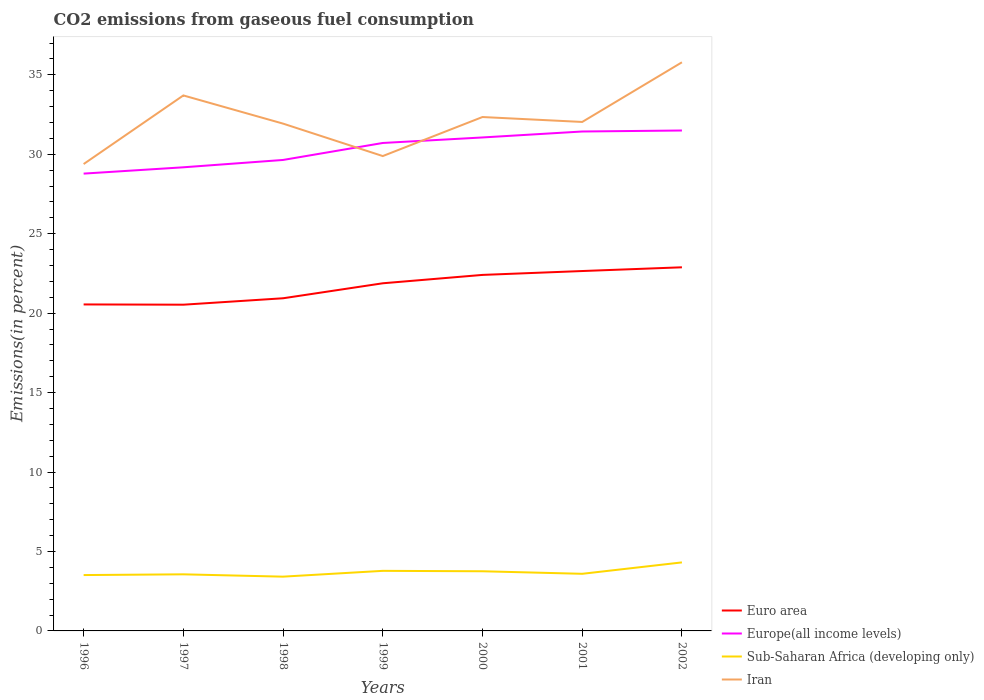Is the number of lines equal to the number of legend labels?
Offer a very short reply. Yes. Across all years, what is the maximum total CO2 emitted in Europe(all income levels)?
Make the answer very short. 28.78. In which year was the total CO2 emitted in Euro area maximum?
Ensure brevity in your answer.  1997. What is the total total CO2 emitted in Sub-Saharan Africa (developing only) in the graph?
Ensure brevity in your answer.  -0.34. What is the difference between the highest and the second highest total CO2 emitted in Iran?
Offer a terse response. 6.4. What is the difference between the highest and the lowest total CO2 emitted in Iran?
Give a very brief answer. 3. How many lines are there?
Offer a terse response. 4. How many years are there in the graph?
Your answer should be very brief. 7. What is the difference between two consecutive major ticks on the Y-axis?
Provide a succinct answer. 5. Does the graph contain grids?
Your answer should be very brief. No. How many legend labels are there?
Offer a very short reply. 4. How are the legend labels stacked?
Provide a succinct answer. Vertical. What is the title of the graph?
Your answer should be very brief. CO2 emissions from gaseous fuel consumption. What is the label or title of the Y-axis?
Your answer should be very brief. Emissions(in percent). What is the Emissions(in percent) of Euro area in 1996?
Make the answer very short. 20.55. What is the Emissions(in percent) of Europe(all income levels) in 1996?
Provide a succinct answer. 28.78. What is the Emissions(in percent) in Sub-Saharan Africa (developing only) in 1996?
Make the answer very short. 3.52. What is the Emissions(in percent) in Iran in 1996?
Ensure brevity in your answer.  29.38. What is the Emissions(in percent) of Euro area in 1997?
Make the answer very short. 20.53. What is the Emissions(in percent) in Europe(all income levels) in 1997?
Make the answer very short. 29.18. What is the Emissions(in percent) in Sub-Saharan Africa (developing only) in 1997?
Give a very brief answer. 3.56. What is the Emissions(in percent) of Iran in 1997?
Your response must be concise. 33.7. What is the Emissions(in percent) in Euro area in 1998?
Provide a succinct answer. 20.94. What is the Emissions(in percent) in Europe(all income levels) in 1998?
Keep it short and to the point. 29.64. What is the Emissions(in percent) of Sub-Saharan Africa (developing only) in 1998?
Your answer should be compact. 3.42. What is the Emissions(in percent) of Iran in 1998?
Ensure brevity in your answer.  31.93. What is the Emissions(in percent) of Euro area in 1999?
Keep it short and to the point. 21.88. What is the Emissions(in percent) in Europe(all income levels) in 1999?
Make the answer very short. 30.71. What is the Emissions(in percent) of Sub-Saharan Africa (developing only) in 1999?
Offer a very short reply. 3.78. What is the Emissions(in percent) of Iran in 1999?
Give a very brief answer. 29.89. What is the Emissions(in percent) in Euro area in 2000?
Your answer should be compact. 22.41. What is the Emissions(in percent) of Europe(all income levels) in 2000?
Make the answer very short. 31.06. What is the Emissions(in percent) of Sub-Saharan Africa (developing only) in 2000?
Your answer should be very brief. 3.75. What is the Emissions(in percent) in Iran in 2000?
Make the answer very short. 32.34. What is the Emissions(in percent) of Euro area in 2001?
Your answer should be very brief. 22.65. What is the Emissions(in percent) in Europe(all income levels) in 2001?
Keep it short and to the point. 31.43. What is the Emissions(in percent) in Sub-Saharan Africa (developing only) in 2001?
Give a very brief answer. 3.59. What is the Emissions(in percent) of Iran in 2001?
Your answer should be compact. 32.03. What is the Emissions(in percent) of Euro area in 2002?
Provide a succinct answer. 22.89. What is the Emissions(in percent) of Europe(all income levels) in 2002?
Ensure brevity in your answer.  31.5. What is the Emissions(in percent) of Sub-Saharan Africa (developing only) in 2002?
Your answer should be compact. 4.31. What is the Emissions(in percent) in Iran in 2002?
Give a very brief answer. 35.79. Across all years, what is the maximum Emissions(in percent) of Euro area?
Ensure brevity in your answer.  22.89. Across all years, what is the maximum Emissions(in percent) in Europe(all income levels)?
Keep it short and to the point. 31.5. Across all years, what is the maximum Emissions(in percent) of Sub-Saharan Africa (developing only)?
Provide a succinct answer. 4.31. Across all years, what is the maximum Emissions(in percent) in Iran?
Offer a terse response. 35.79. Across all years, what is the minimum Emissions(in percent) in Euro area?
Keep it short and to the point. 20.53. Across all years, what is the minimum Emissions(in percent) of Europe(all income levels)?
Offer a very short reply. 28.78. Across all years, what is the minimum Emissions(in percent) in Sub-Saharan Africa (developing only)?
Offer a very short reply. 3.42. Across all years, what is the minimum Emissions(in percent) of Iran?
Make the answer very short. 29.38. What is the total Emissions(in percent) in Euro area in the graph?
Your response must be concise. 151.84. What is the total Emissions(in percent) in Europe(all income levels) in the graph?
Your answer should be very brief. 212.3. What is the total Emissions(in percent) in Sub-Saharan Africa (developing only) in the graph?
Your answer should be very brief. 25.94. What is the total Emissions(in percent) of Iran in the graph?
Your answer should be compact. 225.07. What is the difference between the Emissions(in percent) of Euro area in 1996 and that in 1997?
Provide a short and direct response. 0.02. What is the difference between the Emissions(in percent) of Europe(all income levels) in 1996 and that in 1997?
Give a very brief answer. -0.4. What is the difference between the Emissions(in percent) in Sub-Saharan Africa (developing only) in 1996 and that in 1997?
Provide a short and direct response. -0.05. What is the difference between the Emissions(in percent) in Iran in 1996 and that in 1997?
Give a very brief answer. -4.32. What is the difference between the Emissions(in percent) in Euro area in 1996 and that in 1998?
Provide a short and direct response. -0.39. What is the difference between the Emissions(in percent) in Europe(all income levels) in 1996 and that in 1998?
Your answer should be compact. -0.86. What is the difference between the Emissions(in percent) in Sub-Saharan Africa (developing only) in 1996 and that in 1998?
Offer a terse response. 0.1. What is the difference between the Emissions(in percent) in Iran in 1996 and that in 1998?
Provide a short and direct response. -2.55. What is the difference between the Emissions(in percent) of Euro area in 1996 and that in 1999?
Your response must be concise. -1.33. What is the difference between the Emissions(in percent) of Europe(all income levels) in 1996 and that in 1999?
Your answer should be compact. -1.93. What is the difference between the Emissions(in percent) in Sub-Saharan Africa (developing only) in 1996 and that in 1999?
Provide a succinct answer. -0.27. What is the difference between the Emissions(in percent) in Iran in 1996 and that in 1999?
Your answer should be compact. -0.5. What is the difference between the Emissions(in percent) in Euro area in 1996 and that in 2000?
Provide a succinct answer. -1.86. What is the difference between the Emissions(in percent) in Europe(all income levels) in 1996 and that in 2000?
Offer a very short reply. -2.28. What is the difference between the Emissions(in percent) in Sub-Saharan Africa (developing only) in 1996 and that in 2000?
Provide a succinct answer. -0.24. What is the difference between the Emissions(in percent) of Iran in 1996 and that in 2000?
Provide a short and direct response. -2.96. What is the difference between the Emissions(in percent) in Euro area in 1996 and that in 2001?
Your response must be concise. -2.1. What is the difference between the Emissions(in percent) in Europe(all income levels) in 1996 and that in 2001?
Provide a short and direct response. -2.65. What is the difference between the Emissions(in percent) of Sub-Saharan Africa (developing only) in 1996 and that in 2001?
Make the answer very short. -0.08. What is the difference between the Emissions(in percent) of Iran in 1996 and that in 2001?
Keep it short and to the point. -2.65. What is the difference between the Emissions(in percent) of Euro area in 1996 and that in 2002?
Provide a succinct answer. -2.34. What is the difference between the Emissions(in percent) in Europe(all income levels) in 1996 and that in 2002?
Your answer should be very brief. -2.71. What is the difference between the Emissions(in percent) of Sub-Saharan Africa (developing only) in 1996 and that in 2002?
Offer a terse response. -0.8. What is the difference between the Emissions(in percent) in Iran in 1996 and that in 2002?
Make the answer very short. -6.4. What is the difference between the Emissions(in percent) in Euro area in 1997 and that in 1998?
Offer a very short reply. -0.4. What is the difference between the Emissions(in percent) of Europe(all income levels) in 1997 and that in 1998?
Offer a terse response. -0.46. What is the difference between the Emissions(in percent) of Sub-Saharan Africa (developing only) in 1997 and that in 1998?
Provide a short and direct response. 0.15. What is the difference between the Emissions(in percent) in Iran in 1997 and that in 1998?
Your answer should be very brief. 1.77. What is the difference between the Emissions(in percent) in Euro area in 1997 and that in 1999?
Keep it short and to the point. -1.35. What is the difference between the Emissions(in percent) in Europe(all income levels) in 1997 and that in 1999?
Make the answer very short. -1.53. What is the difference between the Emissions(in percent) of Sub-Saharan Africa (developing only) in 1997 and that in 1999?
Offer a terse response. -0.22. What is the difference between the Emissions(in percent) in Iran in 1997 and that in 1999?
Offer a very short reply. 3.82. What is the difference between the Emissions(in percent) of Euro area in 1997 and that in 2000?
Give a very brief answer. -1.87. What is the difference between the Emissions(in percent) of Europe(all income levels) in 1997 and that in 2000?
Your answer should be compact. -1.88. What is the difference between the Emissions(in percent) of Sub-Saharan Africa (developing only) in 1997 and that in 2000?
Make the answer very short. -0.19. What is the difference between the Emissions(in percent) of Iran in 1997 and that in 2000?
Keep it short and to the point. 1.36. What is the difference between the Emissions(in percent) of Euro area in 1997 and that in 2001?
Offer a very short reply. -2.12. What is the difference between the Emissions(in percent) in Europe(all income levels) in 1997 and that in 2001?
Your response must be concise. -2.25. What is the difference between the Emissions(in percent) in Sub-Saharan Africa (developing only) in 1997 and that in 2001?
Offer a very short reply. -0.03. What is the difference between the Emissions(in percent) of Iran in 1997 and that in 2001?
Your response must be concise. 1.67. What is the difference between the Emissions(in percent) of Euro area in 1997 and that in 2002?
Offer a terse response. -2.35. What is the difference between the Emissions(in percent) in Europe(all income levels) in 1997 and that in 2002?
Provide a succinct answer. -2.32. What is the difference between the Emissions(in percent) in Sub-Saharan Africa (developing only) in 1997 and that in 2002?
Keep it short and to the point. -0.75. What is the difference between the Emissions(in percent) of Iran in 1997 and that in 2002?
Ensure brevity in your answer.  -2.09. What is the difference between the Emissions(in percent) in Euro area in 1998 and that in 1999?
Provide a succinct answer. -0.94. What is the difference between the Emissions(in percent) in Europe(all income levels) in 1998 and that in 1999?
Offer a terse response. -1.07. What is the difference between the Emissions(in percent) in Sub-Saharan Africa (developing only) in 1998 and that in 1999?
Offer a very short reply. -0.37. What is the difference between the Emissions(in percent) in Iran in 1998 and that in 1999?
Your answer should be very brief. 2.04. What is the difference between the Emissions(in percent) in Euro area in 1998 and that in 2000?
Keep it short and to the point. -1.47. What is the difference between the Emissions(in percent) in Europe(all income levels) in 1998 and that in 2000?
Give a very brief answer. -1.42. What is the difference between the Emissions(in percent) in Sub-Saharan Africa (developing only) in 1998 and that in 2000?
Give a very brief answer. -0.34. What is the difference between the Emissions(in percent) of Iran in 1998 and that in 2000?
Provide a short and direct response. -0.41. What is the difference between the Emissions(in percent) of Euro area in 1998 and that in 2001?
Provide a short and direct response. -1.71. What is the difference between the Emissions(in percent) in Europe(all income levels) in 1998 and that in 2001?
Offer a very short reply. -1.79. What is the difference between the Emissions(in percent) of Sub-Saharan Africa (developing only) in 1998 and that in 2001?
Offer a terse response. -0.18. What is the difference between the Emissions(in percent) of Iran in 1998 and that in 2001?
Ensure brevity in your answer.  -0.1. What is the difference between the Emissions(in percent) in Euro area in 1998 and that in 2002?
Give a very brief answer. -1.95. What is the difference between the Emissions(in percent) in Europe(all income levels) in 1998 and that in 2002?
Your response must be concise. -1.85. What is the difference between the Emissions(in percent) of Sub-Saharan Africa (developing only) in 1998 and that in 2002?
Your answer should be very brief. -0.9. What is the difference between the Emissions(in percent) of Iran in 1998 and that in 2002?
Make the answer very short. -3.86. What is the difference between the Emissions(in percent) of Euro area in 1999 and that in 2000?
Provide a succinct answer. -0.53. What is the difference between the Emissions(in percent) of Europe(all income levels) in 1999 and that in 2000?
Your answer should be compact. -0.35. What is the difference between the Emissions(in percent) in Sub-Saharan Africa (developing only) in 1999 and that in 2000?
Offer a terse response. 0.03. What is the difference between the Emissions(in percent) in Iran in 1999 and that in 2000?
Give a very brief answer. -2.46. What is the difference between the Emissions(in percent) in Euro area in 1999 and that in 2001?
Your answer should be compact. -0.77. What is the difference between the Emissions(in percent) of Europe(all income levels) in 1999 and that in 2001?
Your answer should be compact. -0.72. What is the difference between the Emissions(in percent) of Sub-Saharan Africa (developing only) in 1999 and that in 2001?
Your answer should be very brief. 0.19. What is the difference between the Emissions(in percent) in Iran in 1999 and that in 2001?
Offer a very short reply. -2.15. What is the difference between the Emissions(in percent) in Euro area in 1999 and that in 2002?
Offer a terse response. -1.01. What is the difference between the Emissions(in percent) of Europe(all income levels) in 1999 and that in 2002?
Keep it short and to the point. -0.78. What is the difference between the Emissions(in percent) of Sub-Saharan Africa (developing only) in 1999 and that in 2002?
Provide a short and direct response. -0.53. What is the difference between the Emissions(in percent) of Iran in 1999 and that in 2002?
Offer a terse response. -5.9. What is the difference between the Emissions(in percent) of Euro area in 2000 and that in 2001?
Your answer should be compact. -0.24. What is the difference between the Emissions(in percent) of Europe(all income levels) in 2000 and that in 2001?
Provide a short and direct response. -0.37. What is the difference between the Emissions(in percent) in Sub-Saharan Africa (developing only) in 2000 and that in 2001?
Your response must be concise. 0.16. What is the difference between the Emissions(in percent) of Iran in 2000 and that in 2001?
Provide a succinct answer. 0.31. What is the difference between the Emissions(in percent) of Euro area in 2000 and that in 2002?
Give a very brief answer. -0.48. What is the difference between the Emissions(in percent) in Europe(all income levels) in 2000 and that in 2002?
Keep it short and to the point. -0.44. What is the difference between the Emissions(in percent) of Sub-Saharan Africa (developing only) in 2000 and that in 2002?
Provide a succinct answer. -0.56. What is the difference between the Emissions(in percent) in Iran in 2000 and that in 2002?
Provide a short and direct response. -3.44. What is the difference between the Emissions(in percent) of Euro area in 2001 and that in 2002?
Provide a short and direct response. -0.24. What is the difference between the Emissions(in percent) in Europe(all income levels) in 2001 and that in 2002?
Your response must be concise. -0.06. What is the difference between the Emissions(in percent) in Sub-Saharan Africa (developing only) in 2001 and that in 2002?
Provide a succinct answer. -0.72. What is the difference between the Emissions(in percent) in Iran in 2001 and that in 2002?
Give a very brief answer. -3.75. What is the difference between the Emissions(in percent) of Euro area in 1996 and the Emissions(in percent) of Europe(all income levels) in 1997?
Your answer should be compact. -8.63. What is the difference between the Emissions(in percent) in Euro area in 1996 and the Emissions(in percent) in Sub-Saharan Africa (developing only) in 1997?
Make the answer very short. 16.99. What is the difference between the Emissions(in percent) of Euro area in 1996 and the Emissions(in percent) of Iran in 1997?
Make the answer very short. -13.15. What is the difference between the Emissions(in percent) in Europe(all income levels) in 1996 and the Emissions(in percent) in Sub-Saharan Africa (developing only) in 1997?
Give a very brief answer. 25.22. What is the difference between the Emissions(in percent) in Europe(all income levels) in 1996 and the Emissions(in percent) in Iran in 1997?
Keep it short and to the point. -4.92. What is the difference between the Emissions(in percent) in Sub-Saharan Africa (developing only) in 1996 and the Emissions(in percent) in Iran in 1997?
Give a very brief answer. -30.19. What is the difference between the Emissions(in percent) in Euro area in 1996 and the Emissions(in percent) in Europe(all income levels) in 1998?
Offer a very short reply. -9.09. What is the difference between the Emissions(in percent) in Euro area in 1996 and the Emissions(in percent) in Sub-Saharan Africa (developing only) in 1998?
Offer a very short reply. 17.13. What is the difference between the Emissions(in percent) in Euro area in 1996 and the Emissions(in percent) in Iran in 1998?
Your answer should be compact. -11.38. What is the difference between the Emissions(in percent) of Europe(all income levels) in 1996 and the Emissions(in percent) of Sub-Saharan Africa (developing only) in 1998?
Your answer should be compact. 25.37. What is the difference between the Emissions(in percent) in Europe(all income levels) in 1996 and the Emissions(in percent) in Iran in 1998?
Give a very brief answer. -3.15. What is the difference between the Emissions(in percent) of Sub-Saharan Africa (developing only) in 1996 and the Emissions(in percent) of Iran in 1998?
Your response must be concise. -28.41. What is the difference between the Emissions(in percent) of Euro area in 1996 and the Emissions(in percent) of Europe(all income levels) in 1999?
Give a very brief answer. -10.16. What is the difference between the Emissions(in percent) of Euro area in 1996 and the Emissions(in percent) of Sub-Saharan Africa (developing only) in 1999?
Your response must be concise. 16.77. What is the difference between the Emissions(in percent) in Euro area in 1996 and the Emissions(in percent) in Iran in 1999?
Your answer should be very brief. -9.34. What is the difference between the Emissions(in percent) of Europe(all income levels) in 1996 and the Emissions(in percent) of Sub-Saharan Africa (developing only) in 1999?
Provide a succinct answer. 25. What is the difference between the Emissions(in percent) in Europe(all income levels) in 1996 and the Emissions(in percent) in Iran in 1999?
Offer a very short reply. -1.1. What is the difference between the Emissions(in percent) of Sub-Saharan Africa (developing only) in 1996 and the Emissions(in percent) of Iran in 1999?
Your answer should be very brief. -26.37. What is the difference between the Emissions(in percent) in Euro area in 1996 and the Emissions(in percent) in Europe(all income levels) in 2000?
Keep it short and to the point. -10.51. What is the difference between the Emissions(in percent) of Euro area in 1996 and the Emissions(in percent) of Sub-Saharan Africa (developing only) in 2000?
Offer a very short reply. 16.79. What is the difference between the Emissions(in percent) in Euro area in 1996 and the Emissions(in percent) in Iran in 2000?
Ensure brevity in your answer.  -11.8. What is the difference between the Emissions(in percent) of Europe(all income levels) in 1996 and the Emissions(in percent) of Sub-Saharan Africa (developing only) in 2000?
Keep it short and to the point. 25.03. What is the difference between the Emissions(in percent) of Europe(all income levels) in 1996 and the Emissions(in percent) of Iran in 2000?
Give a very brief answer. -3.56. What is the difference between the Emissions(in percent) in Sub-Saharan Africa (developing only) in 1996 and the Emissions(in percent) in Iran in 2000?
Provide a succinct answer. -28.83. What is the difference between the Emissions(in percent) of Euro area in 1996 and the Emissions(in percent) of Europe(all income levels) in 2001?
Give a very brief answer. -10.88. What is the difference between the Emissions(in percent) in Euro area in 1996 and the Emissions(in percent) in Sub-Saharan Africa (developing only) in 2001?
Offer a terse response. 16.95. What is the difference between the Emissions(in percent) of Euro area in 1996 and the Emissions(in percent) of Iran in 2001?
Your answer should be compact. -11.49. What is the difference between the Emissions(in percent) of Europe(all income levels) in 1996 and the Emissions(in percent) of Sub-Saharan Africa (developing only) in 2001?
Give a very brief answer. 25.19. What is the difference between the Emissions(in percent) of Europe(all income levels) in 1996 and the Emissions(in percent) of Iran in 2001?
Your answer should be compact. -3.25. What is the difference between the Emissions(in percent) in Sub-Saharan Africa (developing only) in 1996 and the Emissions(in percent) in Iran in 2001?
Keep it short and to the point. -28.52. What is the difference between the Emissions(in percent) of Euro area in 1996 and the Emissions(in percent) of Europe(all income levels) in 2002?
Your answer should be compact. -10.95. What is the difference between the Emissions(in percent) in Euro area in 1996 and the Emissions(in percent) in Sub-Saharan Africa (developing only) in 2002?
Ensure brevity in your answer.  16.24. What is the difference between the Emissions(in percent) in Euro area in 1996 and the Emissions(in percent) in Iran in 2002?
Your answer should be very brief. -15.24. What is the difference between the Emissions(in percent) of Europe(all income levels) in 1996 and the Emissions(in percent) of Sub-Saharan Africa (developing only) in 2002?
Provide a succinct answer. 24.47. What is the difference between the Emissions(in percent) in Europe(all income levels) in 1996 and the Emissions(in percent) in Iran in 2002?
Ensure brevity in your answer.  -7.01. What is the difference between the Emissions(in percent) of Sub-Saharan Africa (developing only) in 1996 and the Emissions(in percent) of Iran in 2002?
Make the answer very short. -32.27. What is the difference between the Emissions(in percent) in Euro area in 1997 and the Emissions(in percent) in Europe(all income levels) in 1998?
Offer a terse response. -9.11. What is the difference between the Emissions(in percent) of Euro area in 1997 and the Emissions(in percent) of Sub-Saharan Africa (developing only) in 1998?
Make the answer very short. 17.12. What is the difference between the Emissions(in percent) of Euro area in 1997 and the Emissions(in percent) of Iran in 1998?
Make the answer very short. -11.4. What is the difference between the Emissions(in percent) in Europe(all income levels) in 1997 and the Emissions(in percent) in Sub-Saharan Africa (developing only) in 1998?
Provide a short and direct response. 25.76. What is the difference between the Emissions(in percent) in Europe(all income levels) in 1997 and the Emissions(in percent) in Iran in 1998?
Your answer should be compact. -2.75. What is the difference between the Emissions(in percent) in Sub-Saharan Africa (developing only) in 1997 and the Emissions(in percent) in Iran in 1998?
Your response must be concise. -28.37. What is the difference between the Emissions(in percent) in Euro area in 1997 and the Emissions(in percent) in Europe(all income levels) in 1999?
Your response must be concise. -10.18. What is the difference between the Emissions(in percent) of Euro area in 1997 and the Emissions(in percent) of Sub-Saharan Africa (developing only) in 1999?
Your answer should be compact. 16.75. What is the difference between the Emissions(in percent) of Euro area in 1997 and the Emissions(in percent) of Iran in 1999?
Make the answer very short. -9.35. What is the difference between the Emissions(in percent) in Europe(all income levels) in 1997 and the Emissions(in percent) in Sub-Saharan Africa (developing only) in 1999?
Provide a succinct answer. 25.4. What is the difference between the Emissions(in percent) in Europe(all income levels) in 1997 and the Emissions(in percent) in Iran in 1999?
Make the answer very short. -0.71. What is the difference between the Emissions(in percent) in Sub-Saharan Africa (developing only) in 1997 and the Emissions(in percent) in Iran in 1999?
Your answer should be very brief. -26.33. What is the difference between the Emissions(in percent) in Euro area in 1997 and the Emissions(in percent) in Europe(all income levels) in 2000?
Give a very brief answer. -10.53. What is the difference between the Emissions(in percent) of Euro area in 1997 and the Emissions(in percent) of Sub-Saharan Africa (developing only) in 2000?
Provide a short and direct response. 16.78. What is the difference between the Emissions(in percent) of Euro area in 1997 and the Emissions(in percent) of Iran in 2000?
Your answer should be very brief. -11.81. What is the difference between the Emissions(in percent) in Europe(all income levels) in 1997 and the Emissions(in percent) in Sub-Saharan Africa (developing only) in 2000?
Your answer should be very brief. 25.43. What is the difference between the Emissions(in percent) of Europe(all income levels) in 1997 and the Emissions(in percent) of Iran in 2000?
Provide a succinct answer. -3.16. What is the difference between the Emissions(in percent) in Sub-Saharan Africa (developing only) in 1997 and the Emissions(in percent) in Iran in 2000?
Give a very brief answer. -28.78. What is the difference between the Emissions(in percent) of Euro area in 1997 and the Emissions(in percent) of Europe(all income levels) in 2001?
Provide a succinct answer. -10.9. What is the difference between the Emissions(in percent) in Euro area in 1997 and the Emissions(in percent) in Sub-Saharan Africa (developing only) in 2001?
Provide a succinct answer. 16.94. What is the difference between the Emissions(in percent) of Euro area in 1997 and the Emissions(in percent) of Iran in 2001?
Your answer should be very brief. -11.5. What is the difference between the Emissions(in percent) in Europe(all income levels) in 1997 and the Emissions(in percent) in Sub-Saharan Africa (developing only) in 2001?
Provide a succinct answer. 25.59. What is the difference between the Emissions(in percent) of Europe(all income levels) in 1997 and the Emissions(in percent) of Iran in 2001?
Ensure brevity in your answer.  -2.85. What is the difference between the Emissions(in percent) of Sub-Saharan Africa (developing only) in 1997 and the Emissions(in percent) of Iran in 2001?
Give a very brief answer. -28.47. What is the difference between the Emissions(in percent) in Euro area in 1997 and the Emissions(in percent) in Europe(all income levels) in 2002?
Offer a very short reply. -10.96. What is the difference between the Emissions(in percent) in Euro area in 1997 and the Emissions(in percent) in Sub-Saharan Africa (developing only) in 2002?
Provide a short and direct response. 16.22. What is the difference between the Emissions(in percent) in Euro area in 1997 and the Emissions(in percent) in Iran in 2002?
Offer a very short reply. -15.26. What is the difference between the Emissions(in percent) in Europe(all income levels) in 1997 and the Emissions(in percent) in Sub-Saharan Africa (developing only) in 2002?
Make the answer very short. 24.87. What is the difference between the Emissions(in percent) of Europe(all income levels) in 1997 and the Emissions(in percent) of Iran in 2002?
Offer a very short reply. -6.61. What is the difference between the Emissions(in percent) in Sub-Saharan Africa (developing only) in 1997 and the Emissions(in percent) in Iran in 2002?
Provide a succinct answer. -32.23. What is the difference between the Emissions(in percent) in Euro area in 1998 and the Emissions(in percent) in Europe(all income levels) in 1999?
Provide a short and direct response. -9.77. What is the difference between the Emissions(in percent) of Euro area in 1998 and the Emissions(in percent) of Sub-Saharan Africa (developing only) in 1999?
Offer a very short reply. 17.16. What is the difference between the Emissions(in percent) of Euro area in 1998 and the Emissions(in percent) of Iran in 1999?
Provide a succinct answer. -8.95. What is the difference between the Emissions(in percent) in Europe(all income levels) in 1998 and the Emissions(in percent) in Sub-Saharan Africa (developing only) in 1999?
Your response must be concise. 25.86. What is the difference between the Emissions(in percent) of Europe(all income levels) in 1998 and the Emissions(in percent) of Iran in 1999?
Offer a terse response. -0.24. What is the difference between the Emissions(in percent) of Sub-Saharan Africa (developing only) in 1998 and the Emissions(in percent) of Iran in 1999?
Your answer should be compact. -26.47. What is the difference between the Emissions(in percent) of Euro area in 1998 and the Emissions(in percent) of Europe(all income levels) in 2000?
Keep it short and to the point. -10.12. What is the difference between the Emissions(in percent) of Euro area in 1998 and the Emissions(in percent) of Sub-Saharan Africa (developing only) in 2000?
Keep it short and to the point. 17.18. What is the difference between the Emissions(in percent) in Euro area in 1998 and the Emissions(in percent) in Iran in 2000?
Your answer should be compact. -11.41. What is the difference between the Emissions(in percent) in Europe(all income levels) in 1998 and the Emissions(in percent) in Sub-Saharan Africa (developing only) in 2000?
Provide a succinct answer. 25.89. What is the difference between the Emissions(in percent) of Europe(all income levels) in 1998 and the Emissions(in percent) of Iran in 2000?
Make the answer very short. -2.7. What is the difference between the Emissions(in percent) of Sub-Saharan Africa (developing only) in 1998 and the Emissions(in percent) of Iran in 2000?
Your answer should be very brief. -28.93. What is the difference between the Emissions(in percent) in Euro area in 1998 and the Emissions(in percent) in Europe(all income levels) in 2001?
Make the answer very short. -10.5. What is the difference between the Emissions(in percent) of Euro area in 1998 and the Emissions(in percent) of Sub-Saharan Africa (developing only) in 2001?
Offer a terse response. 17.34. What is the difference between the Emissions(in percent) of Euro area in 1998 and the Emissions(in percent) of Iran in 2001?
Your answer should be compact. -11.1. What is the difference between the Emissions(in percent) in Europe(all income levels) in 1998 and the Emissions(in percent) in Sub-Saharan Africa (developing only) in 2001?
Your answer should be very brief. 26.05. What is the difference between the Emissions(in percent) in Europe(all income levels) in 1998 and the Emissions(in percent) in Iran in 2001?
Provide a succinct answer. -2.39. What is the difference between the Emissions(in percent) of Sub-Saharan Africa (developing only) in 1998 and the Emissions(in percent) of Iran in 2001?
Your response must be concise. -28.62. What is the difference between the Emissions(in percent) in Euro area in 1998 and the Emissions(in percent) in Europe(all income levels) in 2002?
Ensure brevity in your answer.  -10.56. What is the difference between the Emissions(in percent) of Euro area in 1998 and the Emissions(in percent) of Sub-Saharan Africa (developing only) in 2002?
Offer a very short reply. 16.62. What is the difference between the Emissions(in percent) of Euro area in 1998 and the Emissions(in percent) of Iran in 2002?
Your answer should be compact. -14.85. What is the difference between the Emissions(in percent) of Europe(all income levels) in 1998 and the Emissions(in percent) of Sub-Saharan Africa (developing only) in 2002?
Keep it short and to the point. 25.33. What is the difference between the Emissions(in percent) of Europe(all income levels) in 1998 and the Emissions(in percent) of Iran in 2002?
Provide a succinct answer. -6.15. What is the difference between the Emissions(in percent) in Sub-Saharan Africa (developing only) in 1998 and the Emissions(in percent) in Iran in 2002?
Your response must be concise. -32.37. What is the difference between the Emissions(in percent) in Euro area in 1999 and the Emissions(in percent) in Europe(all income levels) in 2000?
Your answer should be compact. -9.18. What is the difference between the Emissions(in percent) in Euro area in 1999 and the Emissions(in percent) in Sub-Saharan Africa (developing only) in 2000?
Your response must be concise. 18.13. What is the difference between the Emissions(in percent) in Euro area in 1999 and the Emissions(in percent) in Iran in 2000?
Make the answer very short. -10.46. What is the difference between the Emissions(in percent) of Europe(all income levels) in 1999 and the Emissions(in percent) of Sub-Saharan Africa (developing only) in 2000?
Give a very brief answer. 26.96. What is the difference between the Emissions(in percent) in Europe(all income levels) in 1999 and the Emissions(in percent) in Iran in 2000?
Your answer should be very brief. -1.63. What is the difference between the Emissions(in percent) in Sub-Saharan Africa (developing only) in 1999 and the Emissions(in percent) in Iran in 2000?
Make the answer very short. -28.56. What is the difference between the Emissions(in percent) of Euro area in 1999 and the Emissions(in percent) of Europe(all income levels) in 2001?
Provide a succinct answer. -9.55. What is the difference between the Emissions(in percent) in Euro area in 1999 and the Emissions(in percent) in Sub-Saharan Africa (developing only) in 2001?
Your answer should be compact. 18.29. What is the difference between the Emissions(in percent) of Euro area in 1999 and the Emissions(in percent) of Iran in 2001?
Make the answer very short. -10.15. What is the difference between the Emissions(in percent) in Europe(all income levels) in 1999 and the Emissions(in percent) in Sub-Saharan Africa (developing only) in 2001?
Offer a very short reply. 27.12. What is the difference between the Emissions(in percent) of Europe(all income levels) in 1999 and the Emissions(in percent) of Iran in 2001?
Make the answer very short. -1.32. What is the difference between the Emissions(in percent) in Sub-Saharan Africa (developing only) in 1999 and the Emissions(in percent) in Iran in 2001?
Provide a succinct answer. -28.25. What is the difference between the Emissions(in percent) in Euro area in 1999 and the Emissions(in percent) in Europe(all income levels) in 2002?
Give a very brief answer. -9.62. What is the difference between the Emissions(in percent) of Euro area in 1999 and the Emissions(in percent) of Sub-Saharan Africa (developing only) in 2002?
Make the answer very short. 17.57. What is the difference between the Emissions(in percent) of Euro area in 1999 and the Emissions(in percent) of Iran in 2002?
Your answer should be compact. -13.91. What is the difference between the Emissions(in percent) of Europe(all income levels) in 1999 and the Emissions(in percent) of Sub-Saharan Africa (developing only) in 2002?
Give a very brief answer. 26.4. What is the difference between the Emissions(in percent) in Europe(all income levels) in 1999 and the Emissions(in percent) in Iran in 2002?
Offer a terse response. -5.08. What is the difference between the Emissions(in percent) of Sub-Saharan Africa (developing only) in 1999 and the Emissions(in percent) of Iran in 2002?
Your answer should be very brief. -32.01. What is the difference between the Emissions(in percent) of Euro area in 2000 and the Emissions(in percent) of Europe(all income levels) in 2001?
Ensure brevity in your answer.  -9.03. What is the difference between the Emissions(in percent) in Euro area in 2000 and the Emissions(in percent) in Sub-Saharan Africa (developing only) in 2001?
Your answer should be very brief. 18.81. What is the difference between the Emissions(in percent) of Euro area in 2000 and the Emissions(in percent) of Iran in 2001?
Your answer should be compact. -9.63. What is the difference between the Emissions(in percent) in Europe(all income levels) in 2000 and the Emissions(in percent) in Sub-Saharan Africa (developing only) in 2001?
Give a very brief answer. 27.46. What is the difference between the Emissions(in percent) in Europe(all income levels) in 2000 and the Emissions(in percent) in Iran in 2001?
Provide a short and direct response. -0.98. What is the difference between the Emissions(in percent) of Sub-Saharan Africa (developing only) in 2000 and the Emissions(in percent) of Iran in 2001?
Offer a very short reply. -28.28. What is the difference between the Emissions(in percent) of Euro area in 2000 and the Emissions(in percent) of Europe(all income levels) in 2002?
Offer a terse response. -9.09. What is the difference between the Emissions(in percent) in Euro area in 2000 and the Emissions(in percent) in Sub-Saharan Africa (developing only) in 2002?
Provide a succinct answer. 18.09. What is the difference between the Emissions(in percent) in Euro area in 2000 and the Emissions(in percent) in Iran in 2002?
Keep it short and to the point. -13.38. What is the difference between the Emissions(in percent) of Europe(all income levels) in 2000 and the Emissions(in percent) of Sub-Saharan Africa (developing only) in 2002?
Offer a very short reply. 26.75. What is the difference between the Emissions(in percent) of Europe(all income levels) in 2000 and the Emissions(in percent) of Iran in 2002?
Make the answer very short. -4.73. What is the difference between the Emissions(in percent) in Sub-Saharan Africa (developing only) in 2000 and the Emissions(in percent) in Iran in 2002?
Make the answer very short. -32.03. What is the difference between the Emissions(in percent) of Euro area in 2001 and the Emissions(in percent) of Europe(all income levels) in 2002?
Make the answer very short. -8.84. What is the difference between the Emissions(in percent) in Euro area in 2001 and the Emissions(in percent) in Sub-Saharan Africa (developing only) in 2002?
Provide a succinct answer. 18.34. What is the difference between the Emissions(in percent) of Euro area in 2001 and the Emissions(in percent) of Iran in 2002?
Provide a short and direct response. -13.14. What is the difference between the Emissions(in percent) of Europe(all income levels) in 2001 and the Emissions(in percent) of Sub-Saharan Africa (developing only) in 2002?
Make the answer very short. 27.12. What is the difference between the Emissions(in percent) of Europe(all income levels) in 2001 and the Emissions(in percent) of Iran in 2002?
Offer a very short reply. -4.36. What is the difference between the Emissions(in percent) in Sub-Saharan Africa (developing only) in 2001 and the Emissions(in percent) in Iran in 2002?
Your answer should be compact. -32.19. What is the average Emissions(in percent) of Euro area per year?
Keep it short and to the point. 21.69. What is the average Emissions(in percent) of Europe(all income levels) per year?
Keep it short and to the point. 30.33. What is the average Emissions(in percent) of Sub-Saharan Africa (developing only) per year?
Your answer should be compact. 3.71. What is the average Emissions(in percent) of Iran per year?
Your answer should be very brief. 32.15. In the year 1996, what is the difference between the Emissions(in percent) of Euro area and Emissions(in percent) of Europe(all income levels)?
Ensure brevity in your answer.  -8.23. In the year 1996, what is the difference between the Emissions(in percent) in Euro area and Emissions(in percent) in Sub-Saharan Africa (developing only)?
Ensure brevity in your answer.  17.03. In the year 1996, what is the difference between the Emissions(in percent) in Euro area and Emissions(in percent) in Iran?
Offer a terse response. -8.84. In the year 1996, what is the difference between the Emissions(in percent) in Europe(all income levels) and Emissions(in percent) in Sub-Saharan Africa (developing only)?
Your answer should be very brief. 25.27. In the year 1996, what is the difference between the Emissions(in percent) in Europe(all income levels) and Emissions(in percent) in Iran?
Keep it short and to the point. -0.6. In the year 1996, what is the difference between the Emissions(in percent) of Sub-Saharan Africa (developing only) and Emissions(in percent) of Iran?
Make the answer very short. -25.87. In the year 1997, what is the difference between the Emissions(in percent) of Euro area and Emissions(in percent) of Europe(all income levels)?
Keep it short and to the point. -8.65. In the year 1997, what is the difference between the Emissions(in percent) of Euro area and Emissions(in percent) of Sub-Saharan Africa (developing only)?
Your answer should be compact. 16.97. In the year 1997, what is the difference between the Emissions(in percent) in Euro area and Emissions(in percent) in Iran?
Make the answer very short. -13.17. In the year 1997, what is the difference between the Emissions(in percent) of Europe(all income levels) and Emissions(in percent) of Sub-Saharan Africa (developing only)?
Keep it short and to the point. 25.62. In the year 1997, what is the difference between the Emissions(in percent) in Europe(all income levels) and Emissions(in percent) in Iran?
Give a very brief answer. -4.52. In the year 1997, what is the difference between the Emissions(in percent) of Sub-Saharan Africa (developing only) and Emissions(in percent) of Iran?
Provide a succinct answer. -30.14. In the year 1998, what is the difference between the Emissions(in percent) of Euro area and Emissions(in percent) of Europe(all income levels)?
Keep it short and to the point. -8.71. In the year 1998, what is the difference between the Emissions(in percent) of Euro area and Emissions(in percent) of Sub-Saharan Africa (developing only)?
Your answer should be compact. 17.52. In the year 1998, what is the difference between the Emissions(in percent) in Euro area and Emissions(in percent) in Iran?
Your answer should be very brief. -10.99. In the year 1998, what is the difference between the Emissions(in percent) of Europe(all income levels) and Emissions(in percent) of Sub-Saharan Africa (developing only)?
Provide a short and direct response. 26.23. In the year 1998, what is the difference between the Emissions(in percent) in Europe(all income levels) and Emissions(in percent) in Iran?
Give a very brief answer. -2.29. In the year 1998, what is the difference between the Emissions(in percent) of Sub-Saharan Africa (developing only) and Emissions(in percent) of Iran?
Offer a very short reply. -28.51. In the year 1999, what is the difference between the Emissions(in percent) in Euro area and Emissions(in percent) in Europe(all income levels)?
Ensure brevity in your answer.  -8.83. In the year 1999, what is the difference between the Emissions(in percent) in Euro area and Emissions(in percent) in Sub-Saharan Africa (developing only)?
Offer a very short reply. 18.1. In the year 1999, what is the difference between the Emissions(in percent) of Euro area and Emissions(in percent) of Iran?
Ensure brevity in your answer.  -8.01. In the year 1999, what is the difference between the Emissions(in percent) of Europe(all income levels) and Emissions(in percent) of Sub-Saharan Africa (developing only)?
Offer a very short reply. 26.93. In the year 1999, what is the difference between the Emissions(in percent) of Europe(all income levels) and Emissions(in percent) of Iran?
Provide a succinct answer. 0.82. In the year 1999, what is the difference between the Emissions(in percent) of Sub-Saharan Africa (developing only) and Emissions(in percent) of Iran?
Make the answer very short. -26.11. In the year 2000, what is the difference between the Emissions(in percent) of Euro area and Emissions(in percent) of Europe(all income levels)?
Give a very brief answer. -8.65. In the year 2000, what is the difference between the Emissions(in percent) of Euro area and Emissions(in percent) of Sub-Saharan Africa (developing only)?
Your answer should be compact. 18.65. In the year 2000, what is the difference between the Emissions(in percent) in Euro area and Emissions(in percent) in Iran?
Provide a short and direct response. -9.94. In the year 2000, what is the difference between the Emissions(in percent) in Europe(all income levels) and Emissions(in percent) in Sub-Saharan Africa (developing only)?
Provide a short and direct response. 27.3. In the year 2000, what is the difference between the Emissions(in percent) in Europe(all income levels) and Emissions(in percent) in Iran?
Your response must be concise. -1.29. In the year 2000, what is the difference between the Emissions(in percent) in Sub-Saharan Africa (developing only) and Emissions(in percent) in Iran?
Keep it short and to the point. -28.59. In the year 2001, what is the difference between the Emissions(in percent) of Euro area and Emissions(in percent) of Europe(all income levels)?
Offer a terse response. -8.78. In the year 2001, what is the difference between the Emissions(in percent) in Euro area and Emissions(in percent) in Sub-Saharan Africa (developing only)?
Ensure brevity in your answer.  19.06. In the year 2001, what is the difference between the Emissions(in percent) of Euro area and Emissions(in percent) of Iran?
Offer a very short reply. -9.38. In the year 2001, what is the difference between the Emissions(in percent) in Europe(all income levels) and Emissions(in percent) in Sub-Saharan Africa (developing only)?
Offer a very short reply. 27.84. In the year 2001, what is the difference between the Emissions(in percent) of Europe(all income levels) and Emissions(in percent) of Iran?
Offer a very short reply. -0.6. In the year 2001, what is the difference between the Emissions(in percent) in Sub-Saharan Africa (developing only) and Emissions(in percent) in Iran?
Your answer should be very brief. -28.44. In the year 2002, what is the difference between the Emissions(in percent) in Euro area and Emissions(in percent) in Europe(all income levels)?
Ensure brevity in your answer.  -8.61. In the year 2002, what is the difference between the Emissions(in percent) of Euro area and Emissions(in percent) of Sub-Saharan Africa (developing only)?
Give a very brief answer. 18.57. In the year 2002, what is the difference between the Emissions(in percent) in Euro area and Emissions(in percent) in Iran?
Your response must be concise. -12.9. In the year 2002, what is the difference between the Emissions(in percent) in Europe(all income levels) and Emissions(in percent) in Sub-Saharan Africa (developing only)?
Provide a succinct answer. 27.18. In the year 2002, what is the difference between the Emissions(in percent) of Europe(all income levels) and Emissions(in percent) of Iran?
Ensure brevity in your answer.  -4.29. In the year 2002, what is the difference between the Emissions(in percent) in Sub-Saharan Africa (developing only) and Emissions(in percent) in Iran?
Offer a very short reply. -31.48. What is the ratio of the Emissions(in percent) in Europe(all income levels) in 1996 to that in 1997?
Offer a very short reply. 0.99. What is the ratio of the Emissions(in percent) in Sub-Saharan Africa (developing only) in 1996 to that in 1997?
Offer a very short reply. 0.99. What is the ratio of the Emissions(in percent) in Iran in 1996 to that in 1997?
Provide a short and direct response. 0.87. What is the ratio of the Emissions(in percent) in Euro area in 1996 to that in 1998?
Provide a short and direct response. 0.98. What is the ratio of the Emissions(in percent) in Europe(all income levels) in 1996 to that in 1998?
Ensure brevity in your answer.  0.97. What is the ratio of the Emissions(in percent) of Sub-Saharan Africa (developing only) in 1996 to that in 1998?
Provide a succinct answer. 1.03. What is the ratio of the Emissions(in percent) in Iran in 1996 to that in 1998?
Your answer should be compact. 0.92. What is the ratio of the Emissions(in percent) of Euro area in 1996 to that in 1999?
Your answer should be very brief. 0.94. What is the ratio of the Emissions(in percent) of Europe(all income levels) in 1996 to that in 1999?
Offer a terse response. 0.94. What is the ratio of the Emissions(in percent) in Sub-Saharan Africa (developing only) in 1996 to that in 1999?
Give a very brief answer. 0.93. What is the ratio of the Emissions(in percent) of Iran in 1996 to that in 1999?
Your answer should be compact. 0.98. What is the ratio of the Emissions(in percent) in Euro area in 1996 to that in 2000?
Provide a succinct answer. 0.92. What is the ratio of the Emissions(in percent) in Europe(all income levels) in 1996 to that in 2000?
Provide a short and direct response. 0.93. What is the ratio of the Emissions(in percent) of Sub-Saharan Africa (developing only) in 1996 to that in 2000?
Offer a very short reply. 0.94. What is the ratio of the Emissions(in percent) of Iran in 1996 to that in 2000?
Provide a succinct answer. 0.91. What is the ratio of the Emissions(in percent) in Euro area in 1996 to that in 2001?
Your answer should be compact. 0.91. What is the ratio of the Emissions(in percent) in Europe(all income levels) in 1996 to that in 2001?
Keep it short and to the point. 0.92. What is the ratio of the Emissions(in percent) in Sub-Saharan Africa (developing only) in 1996 to that in 2001?
Your answer should be very brief. 0.98. What is the ratio of the Emissions(in percent) in Iran in 1996 to that in 2001?
Your answer should be very brief. 0.92. What is the ratio of the Emissions(in percent) of Euro area in 1996 to that in 2002?
Offer a terse response. 0.9. What is the ratio of the Emissions(in percent) in Europe(all income levels) in 1996 to that in 2002?
Offer a very short reply. 0.91. What is the ratio of the Emissions(in percent) of Sub-Saharan Africa (developing only) in 1996 to that in 2002?
Your answer should be very brief. 0.82. What is the ratio of the Emissions(in percent) of Iran in 1996 to that in 2002?
Give a very brief answer. 0.82. What is the ratio of the Emissions(in percent) of Euro area in 1997 to that in 1998?
Make the answer very short. 0.98. What is the ratio of the Emissions(in percent) of Europe(all income levels) in 1997 to that in 1998?
Your answer should be very brief. 0.98. What is the ratio of the Emissions(in percent) of Sub-Saharan Africa (developing only) in 1997 to that in 1998?
Ensure brevity in your answer.  1.04. What is the ratio of the Emissions(in percent) in Iran in 1997 to that in 1998?
Ensure brevity in your answer.  1.06. What is the ratio of the Emissions(in percent) of Euro area in 1997 to that in 1999?
Ensure brevity in your answer.  0.94. What is the ratio of the Emissions(in percent) of Europe(all income levels) in 1997 to that in 1999?
Your response must be concise. 0.95. What is the ratio of the Emissions(in percent) in Sub-Saharan Africa (developing only) in 1997 to that in 1999?
Your answer should be compact. 0.94. What is the ratio of the Emissions(in percent) in Iran in 1997 to that in 1999?
Ensure brevity in your answer.  1.13. What is the ratio of the Emissions(in percent) of Euro area in 1997 to that in 2000?
Provide a short and direct response. 0.92. What is the ratio of the Emissions(in percent) in Europe(all income levels) in 1997 to that in 2000?
Provide a short and direct response. 0.94. What is the ratio of the Emissions(in percent) in Sub-Saharan Africa (developing only) in 1997 to that in 2000?
Ensure brevity in your answer.  0.95. What is the ratio of the Emissions(in percent) of Iran in 1997 to that in 2000?
Provide a succinct answer. 1.04. What is the ratio of the Emissions(in percent) in Euro area in 1997 to that in 2001?
Provide a short and direct response. 0.91. What is the ratio of the Emissions(in percent) of Europe(all income levels) in 1997 to that in 2001?
Your response must be concise. 0.93. What is the ratio of the Emissions(in percent) in Sub-Saharan Africa (developing only) in 1997 to that in 2001?
Provide a succinct answer. 0.99. What is the ratio of the Emissions(in percent) in Iran in 1997 to that in 2001?
Offer a terse response. 1.05. What is the ratio of the Emissions(in percent) in Euro area in 1997 to that in 2002?
Keep it short and to the point. 0.9. What is the ratio of the Emissions(in percent) in Europe(all income levels) in 1997 to that in 2002?
Your answer should be very brief. 0.93. What is the ratio of the Emissions(in percent) of Sub-Saharan Africa (developing only) in 1997 to that in 2002?
Offer a very short reply. 0.83. What is the ratio of the Emissions(in percent) in Iran in 1997 to that in 2002?
Ensure brevity in your answer.  0.94. What is the ratio of the Emissions(in percent) in Euro area in 1998 to that in 1999?
Your answer should be compact. 0.96. What is the ratio of the Emissions(in percent) in Europe(all income levels) in 1998 to that in 1999?
Your answer should be very brief. 0.97. What is the ratio of the Emissions(in percent) in Sub-Saharan Africa (developing only) in 1998 to that in 1999?
Your answer should be compact. 0.9. What is the ratio of the Emissions(in percent) in Iran in 1998 to that in 1999?
Provide a succinct answer. 1.07. What is the ratio of the Emissions(in percent) of Euro area in 1998 to that in 2000?
Ensure brevity in your answer.  0.93. What is the ratio of the Emissions(in percent) of Europe(all income levels) in 1998 to that in 2000?
Offer a very short reply. 0.95. What is the ratio of the Emissions(in percent) of Sub-Saharan Africa (developing only) in 1998 to that in 2000?
Offer a very short reply. 0.91. What is the ratio of the Emissions(in percent) in Iran in 1998 to that in 2000?
Give a very brief answer. 0.99. What is the ratio of the Emissions(in percent) of Euro area in 1998 to that in 2001?
Make the answer very short. 0.92. What is the ratio of the Emissions(in percent) in Europe(all income levels) in 1998 to that in 2001?
Your answer should be very brief. 0.94. What is the ratio of the Emissions(in percent) of Sub-Saharan Africa (developing only) in 1998 to that in 2001?
Your answer should be very brief. 0.95. What is the ratio of the Emissions(in percent) in Euro area in 1998 to that in 2002?
Provide a short and direct response. 0.91. What is the ratio of the Emissions(in percent) in Europe(all income levels) in 1998 to that in 2002?
Give a very brief answer. 0.94. What is the ratio of the Emissions(in percent) of Sub-Saharan Africa (developing only) in 1998 to that in 2002?
Ensure brevity in your answer.  0.79. What is the ratio of the Emissions(in percent) of Iran in 1998 to that in 2002?
Your answer should be compact. 0.89. What is the ratio of the Emissions(in percent) of Euro area in 1999 to that in 2000?
Your response must be concise. 0.98. What is the ratio of the Emissions(in percent) of Sub-Saharan Africa (developing only) in 1999 to that in 2000?
Provide a succinct answer. 1.01. What is the ratio of the Emissions(in percent) in Iran in 1999 to that in 2000?
Provide a succinct answer. 0.92. What is the ratio of the Emissions(in percent) in Europe(all income levels) in 1999 to that in 2001?
Offer a terse response. 0.98. What is the ratio of the Emissions(in percent) in Sub-Saharan Africa (developing only) in 1999 to that in 2001?
Provide a short and direct response. 1.05. What is the ratio of the Emissions(in percent) of Iran in 1999 to that in 2001?
Ensure brevity in your answer.  0.93. What is the ratio of the Emissions(in percent) of Euro area in 1999 to that in 2002?
Your answer should be compact. 0.96. What is the ratio of the Emissions(in percent) in Europe(all income levels) in 1999 to that in 2002?
Give a very brief answer. 0.98. What is the ratio of the Emissions(in percent) of Sub-Saharan Africa (developing only) in 1999 to that in 2002?
Ensure brevity in your answer.  0.88. What is the ratio of the Emissions(in percent) of Iran in 1999 to that in 2002?
Your answer should be compact. 0.84. What is the ratio of the Emissions(in percent) in Europe(all income levels) in 2000 to that in 2001?
Offer a very short reply. 0.99. What is the ratio of the Emissions(in percent) in Sub-Saharan Africa (developing only) in 2000 to that in 2001?
Your response must be concise. 1.04. What is the ratio of the Emissions(in percent) in Iran in 2000 to that in 2001?
Keep it short and to the point. 1.01. What is the ratio of the Emissions(in percent) in Euro area in 2000 to that in 2002?
Give a very brief answer. 0.98. What is the ratio of the Emissions(in percent) of Europe(all income levels) in 2000 to that in 2002?
Keep it short and to the point. 0.99. What is the ratio of the Emissions(in percent) of Sub-Saharan Africa (developing only) in 2000 to that in 2002?
Make the answer very short. 0.87. What is the ratio of the Emissions(in percent) of Iran in 2000 to that in 2002?
Provide a succinct answer. 0.9. What is the ratio of the Emissions(in percent) of Euro area in 2001 to that in 2002?
Ensure brevity in your answer.  0.99. What is the ratio of the Emissions(in percent) in Sub-Saharan Africa (developing only) in 2001 to that in 2002?
Offer a terse response. 0.83. What is the ratio of the Emissions(in percent) of Iran in 2001 to that in 2002?
Make the answer very short. 0.9. What is the difference between the highest and the second highest Emissions(in percent) of Euro area?
Ensure brevity in your answer.  0.24. What is the difference between the highest and the second highest Emissions(in percent) of Europe(all income levels)?
Provide a short and direct response. 0.06. What is the difference between the highest and the second highest Emissions(in percent) of Sub-Saharan Africa (developing only)?
Offer a terse response. 0.53. What is the difference between the highest and the second highest Emissions(in percent) of Iran?
Provide a short and direct response. 2.09. What is the difference between the highest and the lowest Emissions(in percent) in Euro area?
Your answer should be very brief. 2.35. What is the difference between the highest and the lowest Emissions(in percent) in Europe(all income levels)?
Provide a succinct answer. 2.71. What is the difference between the highest and the lowest Emissions(in percent) in Sub-Saharan Africa (developing only)?
Offer a terse response. 0.9. What is the difference between the highest and the lowest Emissions(in percent) of Iran?
Ensure brevity in your answer.  6.4. 